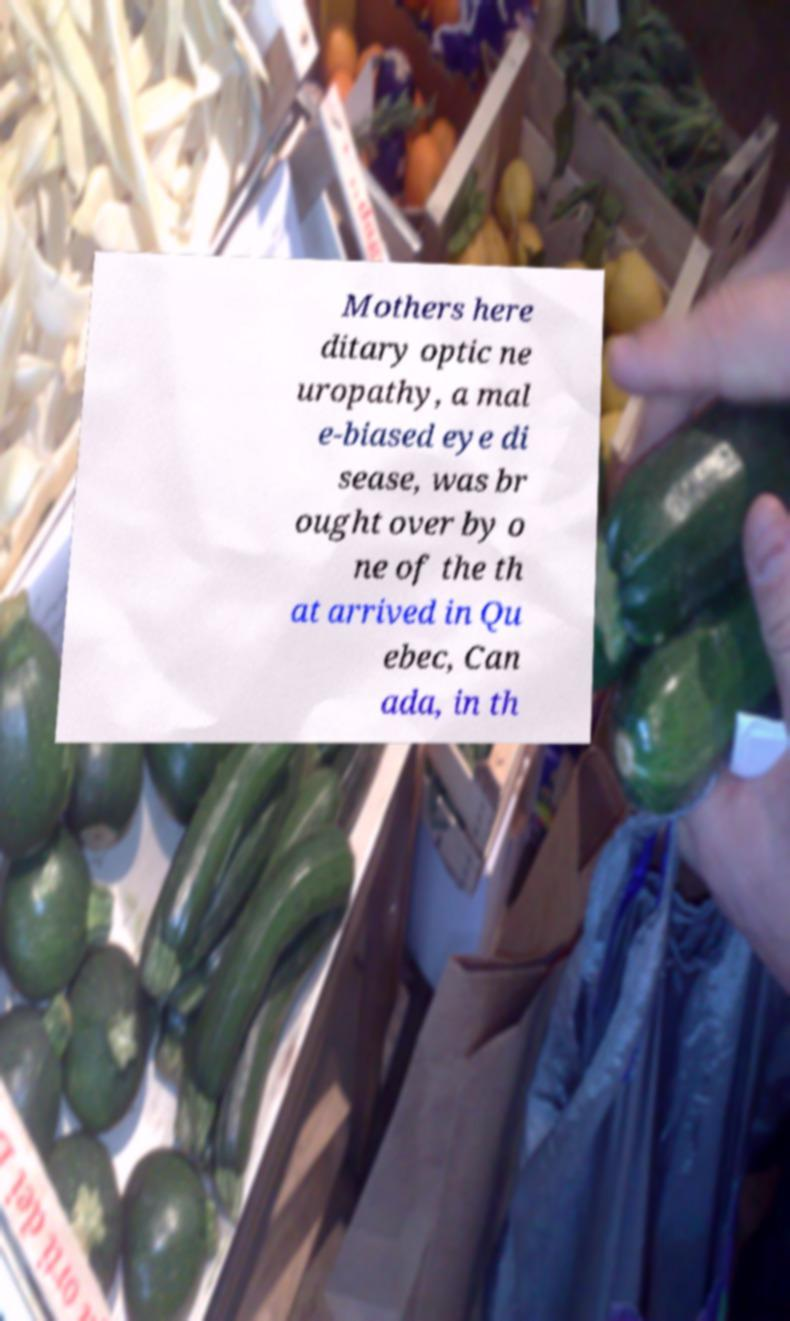There's text embedded in this image that I need extracted. Can you transcribe it verbatim? Mothers here ditary optic ne uropathy, a mal e-biased eye di sease, was br ought over by o ne of the th at arrived in Qu ebec, Can ada, in th 